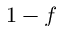<formula> <loc_0><loc_0><loc_500><loc_500>1 - f</formula> 